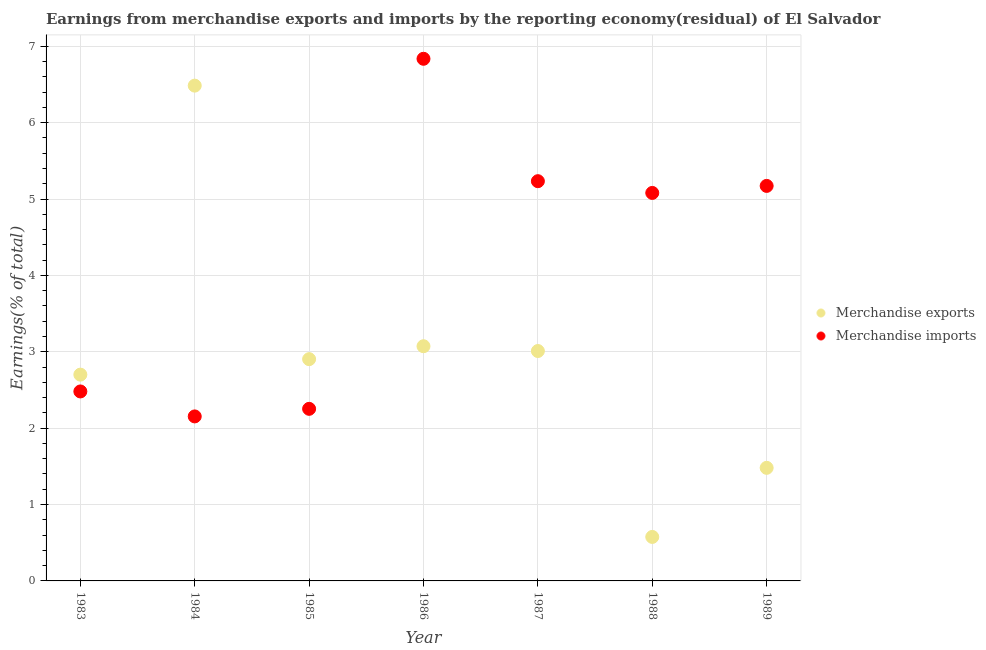What is the earnings from merchandise imports in 1988?
Give a very brief answer. 5.08. Across all years, what is the maximum earnings from merchandise imports?
Give a very brief answer. 6.84. Across all years, what is the minimum earnings from merchandise imports?
Offer a very short reply. 2.15. In which year was the earnings from merchandise imports minimum?
Provide a short and direct response. 1984. What is the total earnings from merchandise exports in the graph?
Give a very brief answer. 20.23. What is the difference between the earnings from merchandise exports in 1983 and that in 1988?
Give a very brief answer. 2.12. What is the difference between the earnings from merchandise imports in 1986 and the earnings from merchandise exports in 1984?
Provide a short and direct response. 0.35. What is the average earnings from merchandise exports per year?
Your answer should be very brief. 2.89. In the year 1987, what is the difference between the earnings from merchandise imports and earnings from merchandise exports?
Provide a short and direct response. 2.22. In how many years, is the earnings from merchandise imports greater than 3.4 %?
Your answer should be very brief. 4. What is the ratio of the earnings from merchandise exports in 1983 to that in 1986?
Your answer should be compact. 0.88. Is the difference between the earnings from merchandise imports in 1984 and 1988 greater than the difference between the earnings from merchandise exports in 1984 and 1988?
Your response must be concise. No. What is the difference between the highest and the second highest earnings from merchandise exports?
Provide a short and direct response. 3.41. What is the difference between the highest and the lowest earnings from merchandise imports?
Give a very brief answer. 4.68. Is the earnings from merchandise exports strictly less than the earnings from merchandise imports over the years?
Provide a succinct answer. No. How many dotlines are there?
Provide a succinct answer. 2. How many years are there in the graph?
Keep it short and to the point. 7. What is the difference between two consecutive major ticks on the Y-axis?
Your response must be concise. 1. Does the graph contain grids?
Keep it short and to the point. Yes. Where does the legend appear in the graph?
Make the answer very short. Center right. How are the legend labels stacked?
Your answer should be very brief. Vertical. What is the title of the graph?
Ensure brevity in your answer.  Earnings from merchandise exports and imports by the reporting economy(residual) of El Salvador. What is the label or title of the Y-axis?
Keep it short and to the point. Earnings(% of total). What is the Earnings(% of total) in Merchandise exports in 1983?
Provide a succinct answer. 2.7. What is the Earnings(% of total) in Merchandise imports in 1983?
Your response must be concise. 2.48. What is the Earnings(% of total) in Merchandise exports in 1984?
Keep it short and to the point. 6.48. What is the Earnings(% of total) of Merchandise imports in 1984?
Your answer should be very brief. 2.15. What is the Earnings(% of total) in Merchandise exports in 1985?
Offer a very short reply. 2.9. What is the Earnings(% of total) in Merchandise imports in 1985?
Your response must be concise. 2.25. What is the Earnings(% of total) of Merchandise exports in 1986?
Offer a terse response. 3.07. What is the Earnings(% of total) of Merchandise imports in 1986?
Offer a very short reply. 6.84. What is the Earnings(% of total) of Merchandise exports in 1987?
Offer a very short reply. 3.01. What is the Earnings(% of total) of Merchandise imports in 1987?
Your response must be concise. 5.23. What is the Earnings(% of total) in Merchandise exports in 1988?
Offer a terse response. 0.58. What is the Earnings(% of total) in Merchandise imports in 1988?
Provide a short and direct response. 5.08. What is the Earnings(% of total) of Merchandise exports in 1989?
Provide a succinct answer. 1.48. What is the Earnings(% of total) of Merchandise imports in 1989?
Offer a terse response. 5.17. Across all years, what is the maximum Earnings(% of total) in Merchandise exports?
Your answer should be compact. 6.48. Across all years, what is the maximum Earnings(% of total) in Merchandise imports?
Keep it short and to the point. 6.84. Across all years, what is the minimum Earnings(% of total) of Merchandise exports?
Offer a very short reply. 0.58. Across all years, what is the minimum Earnings(% of total) in Merchandise imports?
Offer a terse response. 2.15. What is the total Earnings(% of total) of Merchandise exports in the graph?
Provide a succinct answer. 20.23. What is the total Earnings(% of total) in Merchandise imports in the graph?
Keep it short and to the point. 29.21. What is the difference between the Earnings(% of total) of Merchandise exports in 1983 and that in 1984?
Give a very brief answer. -3.78. What is the difference between the Earnings(% of total) in Merchandise imports in 1983 and that in 1984?
Offer a terse response. 0.33. What is the difference between the Earnings(% of total) in Merchandise exports in 1983 and that in 1985?
Your answer should be very brief. -0.2. What is the difference between the Earnings(% of total) of Merchandise imports in 1983 and that in 1985?
Offer a terse response. 0.23. What is the difference between the Earnings(% of total) of Merchandise exports in 1983 and that in 1986?
Give a very brief answer. -0.37. What is the difference between the Earnings(% of total) in Merchandise imports in 1983 and that in 1986?
Offer a terse response. -4.36. What is the difference between the Earnings(% of total) in Merchandise exports in 1983 and that in 1987?
Provide a succinct answer. -0.31. What is the difference between the Earnings(% of total) of Merchandise imports in 1983 and that in 1987?
Make the answer very short. -2.75. What is the difference between the Earnings(% of total) in Merchandise exports in 1983 and that in 1988?
Offer a terse response. 2.12. What is the difference between the Earnings(% of total) of Merchandise imports in 1983 and that in 1988?
Provide a succinct answer. -2.6. What is the difference between the Earnings(% of total) of Merchandise exports in 1983 and that in 1989?
Offer a very short reply. 1.22. What is the difference between the Earnings(% of total) in Merchandise imports in 1983 and that in 1989?
Keep it short and to the point. -2.69. What is the difference between the Earnings(% of total) of Merchandise exports in 1984 and that in 1985?
Offer a terse response. 3.58. What is the difference between the Earnings(% of total) in Merchandise imports in 1984 and that in 1985?
Offer a terse response. -0.1. What is the difference between the Earnings(% of total) of Merchandise exports in 1984 and that in 1986?
Your answer should be compact. 3.41. What is the difference between the Earnings(% of total) in Merchandise imports in 1984 and that in 1986?
Keep it short and to the point. -4.68. What is the difference between the Earnings(% of total) of Merchandise exports in 1984 and that in 1987?
Provide a short and direct response. 3.47. What is the difference between the Earnings(% of total) in Merchandise imports in 1984 and that in 1987?
Keep it short and to the point. -3.08. What is the difference between the Earnings(% of total) of Merchandise exports in 1984 and that in 1988?
Give a very brief answer. 5.91. What is the difference between the Earnings(% of total) of Merchandise imports in 1984 and that in 1988?
Offer a terse response. -2.93. What is the difference between the Earnings(% of total) of Merchandise exports in 1984 and that in 1989?
Give a very brief answer. 5. What is the difference between the Earnings(% of total) of Merchandise imports in 1984 and that in 1989?
Make the answer very short. -3.02. What is the difference between the Earnings(% of total) of Merchandise exports in 1985 and that in 1986?
Provide a succinct answer. -0.17. What is the difference between the Earnings(% of total) of Merchandise imports in 1985 and that in 1986?
Ensure brevity in your answer.  -4.58. What is the difference between the Earnings(% of total) of Merchandise exports in 1985 and that in 1987?
Your answer should be very brief. -0.11. What is the difference between the Earnings(% of total) of Merchandise imports in 1985 and that in 1987?
Your answer should be compact. -2.98. What is the difference between the Earnings(% of total) in Merchandise exports in 1985 and that in 1988?
Provide a succinct answer. 2.33. What is the difference between the Earnings(% of total) of Merchandise imports in 1985 and that in 1988?
Your answer should be compact. -2.83. What is the difference between the Earnings(% of total) in Merchandise exports in 1985 and that in 1989?
Provide a succinct answer. 1.42. What is the difference between the Earnings(% of total) of Merchandise imports in 1985 and that in 1989?
Your answer should be compact. -2.92. What is the difference between the Earnings(% of total) of Merchandise exports in 1986 and that in 1987?
Your response must be concise. 0.06. What is the difference between the Earnings(% of total) of Merchandise imports in 1986 and that in 1987?
Keep it short and to the point. 1.6. What is the difference between the Earnings(% of total) of Merchandise exports in 1986 and that in 1988?
Offer a very short reply. 2.5. What is the difference between the Earnings(% of total) in Merchandise imports in 1986 and that in 1988?
Your answer should be compact. 1.76. What is the difference between the Earnings(% of total) of Merchandise exports in 1986 and that in 1989?
Your answer should be compact. 1.59. What is the difference between the Earnings(% of total) of Merchandise imports in 1986 and that in 1989?
Provide a succinct answer. 1.66. What is the difference between the Earnings(% of total) in Merchandise exports in 1987 and that in 1988?
Ensure brevity in your answer.  2.43. What is the difference between the Earnings(% of total) in Merchandise imports in 1987 and that in 1988?
Your response must be concise. 0.15. What is the difference between the Earnings(% of total) of Merchandise exports in 1987 and that in 1989?
Your response must be concise. 1.53. What is the difference between the Earnings(% of total) of Merchandise imports in 1987 and that in 1989?
Ensure brevity in your answer.  0.06. What is the difference between the Earnings(% of total) in Merchandise exports in 1988 and that in 1989?
Keep it short and to the point. -0.9. What is the difference between the Earnings(% of total) of Merchandise imports in 1988 and that in 1989?
Keep it short and to the point. -0.09. What is the difference between the Earnings(% of total) in Merchandise exports in 1983 and the Earnings(% of total) in Merchandise imports in 1984?
Provide a short and direct response. 0.55. What is the difference between the Earnings(% of total) of Merchandise exports in 1983 and the Earnings(% of total) of Merchandise imports in 1985?
Provide a short and direct response. 0.45. What is the difference between the Earnings(% of total) of Merchandise exports in 1983 and the Earnings(% of total) of Merchandise imports in 1986?
Provide a succinct answer. -4.14. What is the difference between the Earnings(% of total) of Merchandise exports in 1983 and the Earnings(% of total) of Merchandise imports in 1987?
Provide a short and direct response. -2.53. What is the difference between the Earnings(% of total) of Merchandise exports in 1983 and the Earnings(% of total) of Merchandise imports in 1988?
Provide a succinct answer. -2.38. What is the difference between the Earnings(% of total) of Merchandise exports in 1983 and the Earnings(% of total) of Merchandise imports in 1989?
Keep it short and to the point. -2.47. What is the difference between the Earnings(% of total) in Merchandise exports in 1984 and the Earnings(% of total) in Merchandise imports in 1985?
Provide a short and direct response. 4.23. What is the difference between the Earnings(% of total) of Merchandise exports in 1984 and the Earnings(% of total) of Merchandise imports in 1986?
Your answer should be compact. -0.35. What is the difference between the Earnings(% of total) in Merchandise exports in 1984 and the Earnings(% of total) in Merchandise imports in 1987?
Your answer should be compact. 1.25. What is the difference between the Earnings(% of total) of Merchandise exports in 1984 and the Earnings(% of total) of Merchandise imports in 1988?
Ensure brevity in your answer.  1.4. What is the difference between the Earnings(% of total) in Merchandise exports in 1984 and the Earnings(% of total) in Merchandise imports in 1989?
Give a very brief answer. 1.31. What is the difference between the Earnings(% of total) of Merchandise exports in 1985 and the Earnings(% of total) of Merchandise imports in 1986?
Offer a terse response. -3.93. What is the difference between the Earnings(% of total) of Merchandise exports in 1985 and the Earnings(% of total) of Merchandise imports in 1987?
Provide a succinct answer. -2.33. What is the difference between the Earnings(% of total) in Merchandise exports in 1985 and the Earnings(% of total) in Merchandise imports in 1988?
Make the answer very short. -2.18. What is the difference between the Earnings(% of total) of Merchandise exports in 1985 and the Earnings(% of total) of Merchandise imports in 1989?
Offer a very short reply. -2.27. What is the difference between the Earnings(% of total) of Merchandise exports in 1986 and the Earnings(% of total) of Merchandise imports in 1987?
Your response must be concise. -2.16. What is the difference between the Earnings(% of total) in Merchandise exports in 1986 and the Earnings(% of total) in Merchandise imports in 1988?
Keep it short and to the point. -2.01. What is the difference between the Earnings(% of total) of Merchandise exports in 1986 and the Earnings(% of total) of Merchandise imports in 1989?
Offer a terse response. -2.1. What is the difference between the Earnings(% of total) in Merchandise exports in 1987 and the Earnings(% of total) in Merchandise imports in 1988?
Your answer should be very brief. -2.07. What is the difference between the Earnings(% of total) of Merchandise exports in 1987 and the Earnings(% of total) of Merchandise imports in 1989?
Give a very brief answer. -2.16. What is the difference between the Earnings(% of total) in Merchandise exports in 1988 and the Earnings(% of total) in Merchandise imports in 1989?
Your response must be concise. -4.6. What is the average Earnings(% of total) in Merchandise exports per year?
Provide a short and direct response. 2.89. What is the average Earnings(% of total) in Merchandise imports per year?
Provide a succinct answer. 4.17. In the year 1983, what is the difference between the Earnings(% of total) of Merchandise exports and Earnings(% of total) of Merchandise imports?
Provide a succinct answer. 0.22. In the year 1984, what is the difference between the Earnings(% of total) in Merchandise exports and Earnings(% of total) in Merchandise imports?
Your response must be concise. 4.33. In the year 1985, what is the difference between the Earnings(% of total) in Merchandise exports and Earnings(% of total) in Merchandise imports?
Provide a succinct answer. 0.65. In the year 1986, what is the difference between the Earnings(% of total) in Merchandise exports and Earnings(% of total) in Merchandise imports?
Make the answer very short. -3.76. In the year 1987, what is the difference between the Earnings(% of total) in Merchandise exports and Earnings(% of total) in Merchandise imports?
Provide a succinct answer. -2.22. In the year 1988, what is the difference between the Earnings(% of total) in Merchandise exports and Earnings(% of total) in Merchandise imports?
Keep it short and to the point. -4.5. In the year 1989, what is the difference between the Earnings(% of total) of Merchandise exports and Earnings(% of total) of Merchandise imports?
Your answer should be compact. -3.69. What is the ratio of the Earnings(% of total) of Merchandise exports in 1983 to that in 1984?
Offer a terse response. 0.42. What is the ratio of the Earnings(% of total) of Merchandise imports in 1983 to that in 1984?
Your response must be concise. 1.15. What is the ratio of the Earnings(% of total) of Merchandise exports in 1983 to that in 1985?
Your answer should be very brief. 0.93. What is the ratio of the Earnings(% of total) of Merchandise imports in 1983 to that in 1985?
Your answer should be very brief. 1.1. What is the ratio of the Earnings(% of total) in Merchandise exports in 1983 to that in 1986?
Your answer should be very brief. 0.88. What is the ratio of the Earnings(% of total) of Merchandise imports in 1983 to that in 1986?
Ensure brevity in your answer.  0.36. What is the ratio of the Earnings(% of total) in Merchandise exports in 1983 to that in 1987?
Provide a short and direct response. 0.9. What is the ratio of the Earnings(% of total) in Merchandise imports in 1983 to that in 1987?
Make the answer very short. 0.47. What is the ratio of the Earnings(% of total) of Merchandise exports in 1983 to that in 1988?
Ensure brevity in your answer.  4.69. What is the ratio of the Earnings(% of total) of Merchandise imports in 1983 to that in 1988?
Provide a short and direct response. 0.49. What is the ratio of the Earnings(% of total) in Merchandise exports in 1983 to that in 1989?
Offer a terse response. 1.82. What is the ratio of the Earnings(% of total) in Merchandise imports in 1983 to that in 1989?
Your response must be concise. 0.48. What is the ratio of the Earnings(% of total) in Merchandise exports in 1984 to that in 1985?
Ensure brevity in your answer.  2.23. What is the ratio of the Earnings(% of total) of Merchandise imports in 1984 to that in 1985?
Your response must be concise. 0.96. What is the ratio of the Earnings(% of total) of Merchandise exports in 1984 to that in 1986?
Keep it short and to the point. 2.11. What is the ratio of the Earnings(% of total) in Merchandise imports in 1984 to that in 1986?
Provide a succinct answer. 0.32. What is the ratio of the Earnings(% of total) in Merchandise exports in 1984 to that in 1987?
Provide a short and direct response. 2.15. What is the ratio of the Earnings(% of total) in Merchandise imports in 1984 to that in 1987?
Your response must be concise. 0.41. What is the ratio of the Earnings(% of total) in Merchandise exports in 1984 to that in 1988?
Your response must be concise. 11.26. What is the ratio of the Earnings(% of total) in Merchandise imports in 1984 to that in 1988?
Offer a terse response. 0.42. What is the ratio of the Earnings(% of total) in Merchandise exports in 1984 to that in 1989?
Give a very brief answer. 4.38. What is the ratio of the Earnings(% of total) in Merchandise imports in 1984 to that in 1989?
Make the answer very short. 0.42. What is the ratio of the Earnings(% of total) of Merchandise exports in 1985 to that in 1986?
Make the answer very short. 0.94. What is the ratio of the Earnings(% of total) of Merchandise imports in 1985 to that in 1986?
Give a very brief answer. 0.33. What is the ratio of the Earnings(% of total) of Merchandise exports in 1985 to that in 1987?
Your response must be concise. 0.96. What is the ratio of the Earnings(% of total) in Merchandise imports in 1985 to that in 1987?
Provide a short and direct response. 0.43. What is the ratio of the Earnings(% of total) in Merchandise exports in 1985 to that in 1988?
Offer a terse response. 5.04. What is the ratio of the Earnings(% of total) of Merchandise imports in 1985 to that in 1988?
Offer a terse response. 0.44. What is the ratio of the Earnings(% of total) of Merchandise exports in 1985 to that in 1989?
Your answer should be very brief. 1.96. What is the ratio of the Earnings(% of total) of Merchandise imports in 1985 to that in 1989?
Your response must be concise. 0.44. What is the ratio of the Earnings(% of total) of Merchandise exports in 1986 to that in 1987?
Offer a terse response. 1.02. What is the ratio of the Earnings(% of total) in Merchandise imports in 1986 to that in 1987?
Ensure brevity in your answer.  1.31. What is the ratio of the Earnings(% of total) in Merchandise exports in 1986 to that in 1988?
Offer a terse response. 5.33. What is the ratio of the Earnings(% of total) in Merchandise imports in 1986 to that in 1988?
Make the answer very short. 1.35. What is the ratio of the Earnings(% of total) in Merchandise exports in 1986 to that in 1989?
Offer a very short reply. 2.08. What is the ratio of the Earnings(% of total) in Merchandise imports in 1986 to that in 1989?
Your answer should be very brief. 1.32. What is the ratio of the Earnings(% of total) in Merchandise exports in 1987 to that in 1988?
Provide a succinct answer. 5.23. What is the ratio of the Earnings(% of total) in Merchandise imports in 1987 to that in 1988?
Offer a very short reply. 1.03. What is the ratio of the Earnings(% of total) of Merchandise exports in 1987 to that in 1989?
Your answer should be compact. 2.03. What is the ratio of the Earnings(% of total) of Merchandise imports in 1987 to that in 1989?
Offer a very short reply. 1.01. What is the ratio of the Earnings(% of total) of Merchandise exports in 1988 to that in 1989?
Your answer should be very brief. 0.39. What is the ratio of the Earnings(% of total) of Merchandise imports in 1988 to that in 1989?
Ensure brevity in your answer.  0.98. What is the difference between the highest and the second highest Earnings(% of total) in Merchandise exports?
Offer a terse response. 3.41. What is the difference between the highest and the second highest Earnings(% of total) in Merchandise imports?
Your response must be concise. 1.6. What is the difference between the highest and the lowest Earnings(% of total) of Merchandise exports?
Provide a short and direct response. 5.91. What is the difference between the highest and the lowest Earnings(% of total) in Merchandise imports?
Offer a terse response. 4.68. 